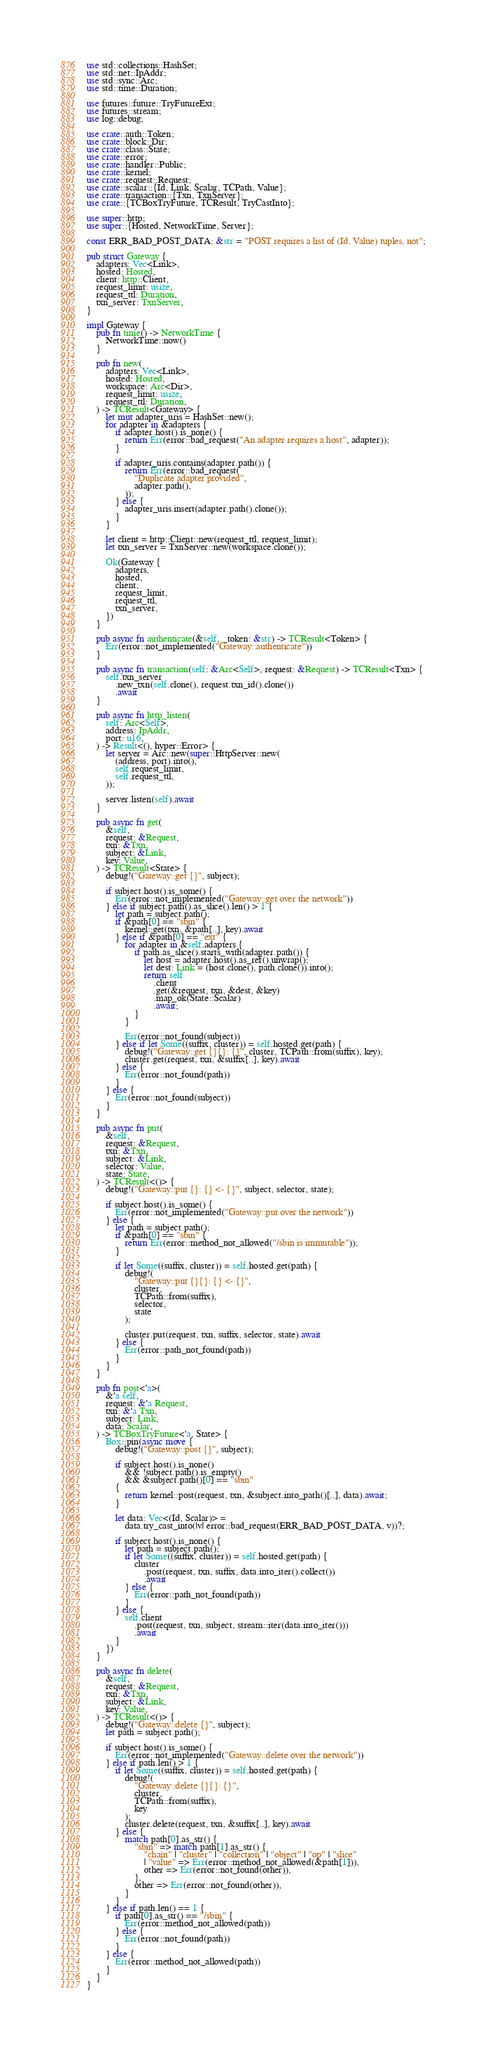Convert code to text. <code><loc_0><loc_0><loc_500><loc_500><_Rust_>use std::collections::HashSet;
use std::net::IpAddr;
use std::sync::Arc;
use std::time::Duration;

use futures::future::TryFutureExt;
use futures::stream;
use log::debug;

use crate::auth::Token;
use crate::block::Dir;
use crate::class::State;
use crate::error;
use crate::handler::Public;
use crate::kernel;
use crate::request::Request;
use crate::scalar::{Id, Link, Scalar, TCPath, Value};
use crate::transaction::{Txn, TxnServer};
use crate::{TCBoxTryFuture, TCResult, TryCastInto};

use super::http;
use super::{Hosted, NetworkTime, Server};

const ERR_BAD_POST_DATA: &str = "POST requires a list of (Id, Value) tuples, not";

pub struct Gateway {
    adapters: Vec<Link>,
    hosted: Hosted,
    client: http::Client,
    request_limit: usize,
    request_ttl: Duration,
    txn_server: TxnServer,
}

impl Gateway {
    pub fn time() -> NetworkTime {
        NetworkTime::now()
    }

    pub fn new(
        adapters: Vec<Link>,
        hosted: Hosted,
        workspace: Arc<Dir>,
        request_limit: usize,
        request_ttl: Duration,
    ) -> TCResult<Gateway> {
        let mut adapter_uris = HashSet::new();
        for adapter in &adapters {
            if adapter.host().is_none() {
                return Err(error::bad_request("An adapter requires a host", adapter));
            }

            if adapter_uris.contains(adapter.path()) {
                return Err(error::bad_request(
                    "Duplicate adapter provided",
                    adapter.path(),
                ));
            } else {
                adapter_uris.insert(adapter.path().clone());
            }
        }

        let client = http::Client::new(request_ttl, request_limit);
        let txn_server = TxnServer::new(workspace.clone());

        Ok(Gateway {
            adapters,
            hosted,
            client,
            request_limit,
            request_ttl,
            txn_server,
        })
    }

    pub async fn authenticate(&self, _token: &str) -> TCResult<Token> {
        Err(error::not_implemented("Gateway::authenticate"))
    }

    pub async fn transaction(self: &Arc<Self>, request: &Request) -> TCResult<Txn> {
        self.txn_server
            .new_txn(self.clone(), request.txn_id().clone())
            .await
    }

    pub async fn http_listen(
        self: Arc<Self>,
        address: IpAddr,
        port: u16,
    ) -> Result<(), hyper::Error> {
        let server = Arc::new(super::HttpServer::new(
            (address, port).into(),
            self.request_limit,
            self.request_ttl,
        ));

        server.listen(self).await
    }

    pub async fn get(
        &self,
        request: &Request,
        txn: &Txn,
        subject: &Link,
        key: Value,
    ) -> TCResult<State> {
        debug!("Gateway::get {}", subject);

        if subject.host().is_some() {
            Err(error::not_implemented("Gateway::get over the network"))
        } else if subject.path().as_slice().len() > 1 {
            let path = subject.path();
            if &path[0] == "sbin" {
                kernel::get(txn, &path[..], key).await
            } else if &path[0] == "ext" {
                for adapter in &self.adapters {
                    if path.as_slice().starts_with(adapter.path()) {
                        let host = adapter.host().as_ref().unwrap();
                        let dest: Link = (host.clone(), path.clone()).into();
                        return self
                            .client
                            .get(&request, txn, &dest, &key)
                            .map_ok(State::Scalar)
                            .await;
                    }
                }

                Err(error::not_found(subject))
            } else if let Some((suffix, cluster)) = self.hosted.get(path) {
                debug!("Gateway::get {}{}: {}", cluster, TCPath::from(suffix), key);
                cluster.get(request, txn, &suffix[..], key).await
            } else {
                Err(error::not_found(path))
            }
        } else {
            Err(error::not_found(subject))
        }
    }

    pub async fn put(
        &self,
        request: &Request,
        txn: &Txn,
        subject: &Link,
        selector: Value,
        state: State,
    ) -> TCResult<()> {
        debug!("Gateway::put {}: {} <- {}", subject, selector, state);

        if subject.host().is_some() {
            Err(error::not_implemented("Gateway::put over the network"))
        } else {
            let path = subject.path();
            if &path[0] == "sbin" {
                return Err(error::method_not_allowed("/sbin is immutable"));
            }

            if let Some((suffix, cluster)) = self.hosted.get(path) {
                debug!(
                    "Gateway::put {}{}: {} <- {}",
                    cluster,
                    TCPath::from(suffix),
                    selector,
                    state
                );

                cluster.put(request, txn, suffix, selector, state).await
            } else {
                Err(error::path_not_found(path))
            }
        }
    }

    pub fn post<'a>(
        &'a self,
        request: &'a Request,
        txn: &'a Txn,
        subject: Link,
        data: Scalar,
    ) -> TCBoxTryFuture<'a, State> {
        Box::pin(async move {
            debug!("Gateway::post {}", subject);

            if subject.host().is_none()
                && !subject.path().is_empty()
                && &subject.path()[0] == "sbin"
            {
                return kernel::post(request, txn, &subject.into_path()[..], data).await;
            }

            let data: Vec<(Id, Scalar)> =
                data.try_cast_into(|v| error::bad_request(ERR_BAD_POST_DATA, v))?;

            if subject.host().is_none() {
                let path = subject.path();
                if let Some((suffix, cluster)) = self.hosted.get(path) {
                    cluster
                        .post(request, txn, suffix, data.into_iter().collect())
                        .await
                } else {
                    Err(error::path_not_found(path))
                }
            } else {
                self.client
                    .post(request, txn, subject, stream::iter(data.into_iter()))
                    .await
            }
        })
    }

    pub async fn delete(
        &self,
        request: &Request,
        txn: &Txn,
        subject: &Link,
        key: Value,
    ) -> TCResult<()> {
        debug!("Gateway::delete {}", subject);
        let path = subject.path();

        if subject.host().is_some() {
            Err(error::not_implemented("Gateway::delete over the network"))
        } else if path.len() > 1 {
            if let Some((suffix, cluster)) = self.hosted.get(path) {
                debug!(
                    "Gateway::delete {}{}: {}",
                    cluster,
                    TCPath::from(suffix),
                    key
                );
                cluster.delete(request, txn, &suffix[..], key).await
            } else {
                match path[0].as_str() {
                    "sbin" => match path[1].as_str() {
                        "chain" | "cluster" | "collection" | "object" | "op" | "slice"
                        | "value" => Err(error::method_not_allowed(&path[1])),
                        other => Err(error::not_found(other)),
                    },
                    other => Err(error::not_found(other)),
                }
            }
        } else if path.len() == 1 {
            if path[0].as_str() == "/sbin" {
                Err(error::method_not_allowed(path))
            } else {
                Err(error::not_found(path))
            }
        } else {
            Err(error::method_not_allowed(path))
        }
    }
}
</code> 